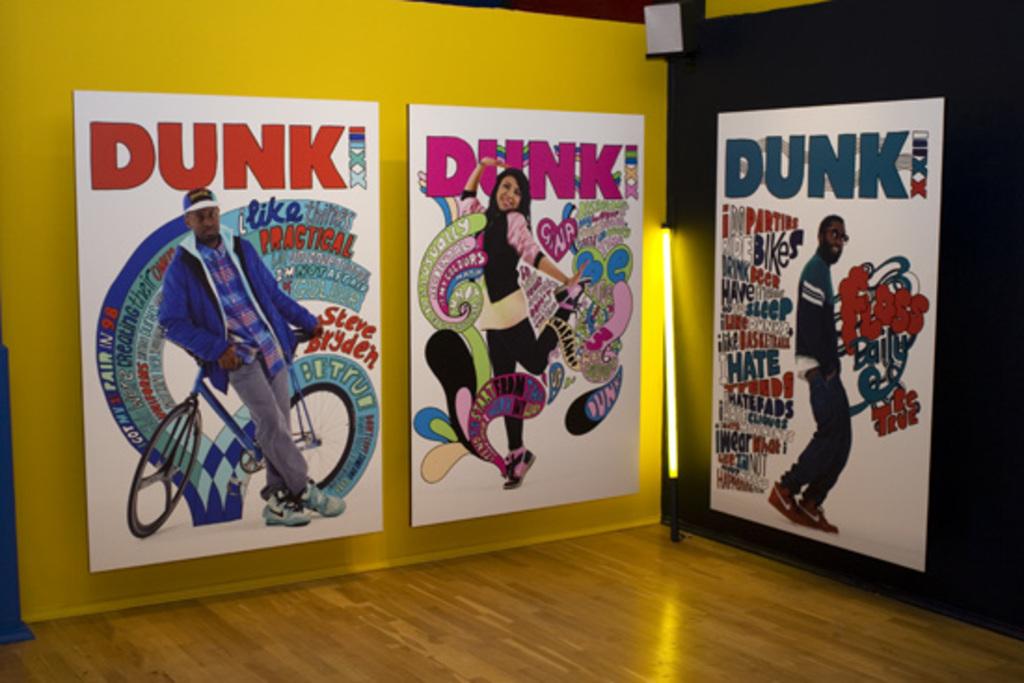What does it say at the top of each poster?
Give a very brief answer. Dunk. 